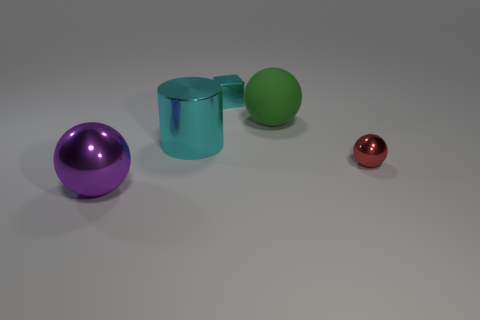Are there any large balls that have the same material as the green thing?
Provide a succinct answer. No. The green thing has what shape?
Provide a short and direct response. Sphere. Is the red thing the same size as the cyan cube?
Offer a very short reply. Yes. How many other things are the same shape as the tiny cyan thing?
Your answer should be very brief. 0. What is the shape of the cyan object behind the large green object?
Your answer should be compact. Cube. There is a metallic thing that is to the right of the small metal block; is its shape the same as the cyan thing that is behind the green sphere?
Provide a succinct answer. No. Are there the same number of red shiny objects that are left of the purple thing and purple shiny balls?
Provide a short and direct response. No. Is there anything else that has the same size as the green rubber object?
Your answer should be very brief. Yes. There is another big purple object that is the same shape as the big matte object; what is it made of?
Keep it short and to the point. Metal. There is a green matte object that is on the right side of the shiny sphere that is to the left of the rubber object; what shape is it?
Ensure brevity in your answer.  Sphere. 